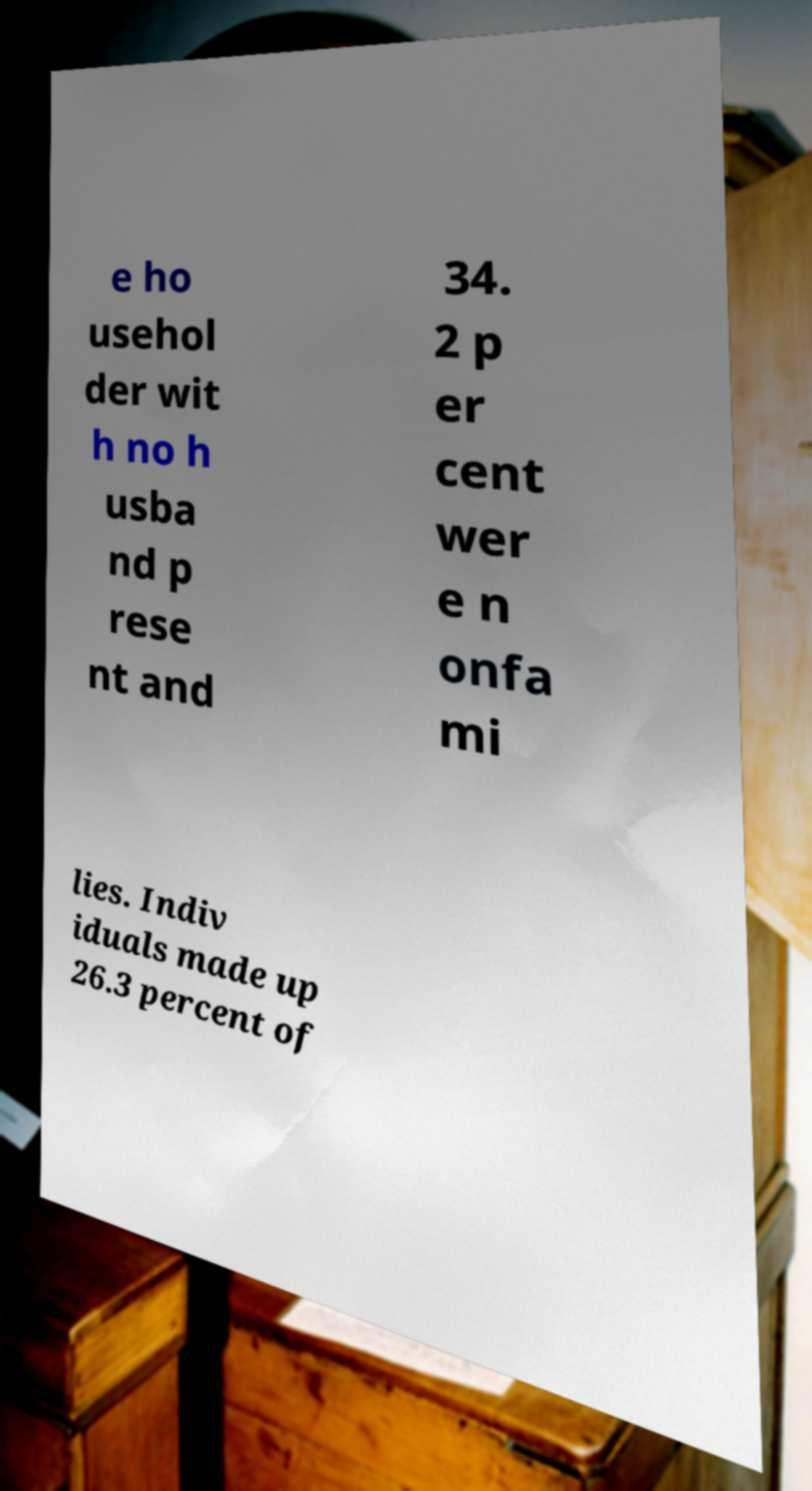Please read and relay the text visible in this image. What does it say? e ho usehol der wit h no h usba nd p rese nt and 34. 2 p er cent wer e n onfa mi lies. Indiv iduals made up 26.3 percent of 